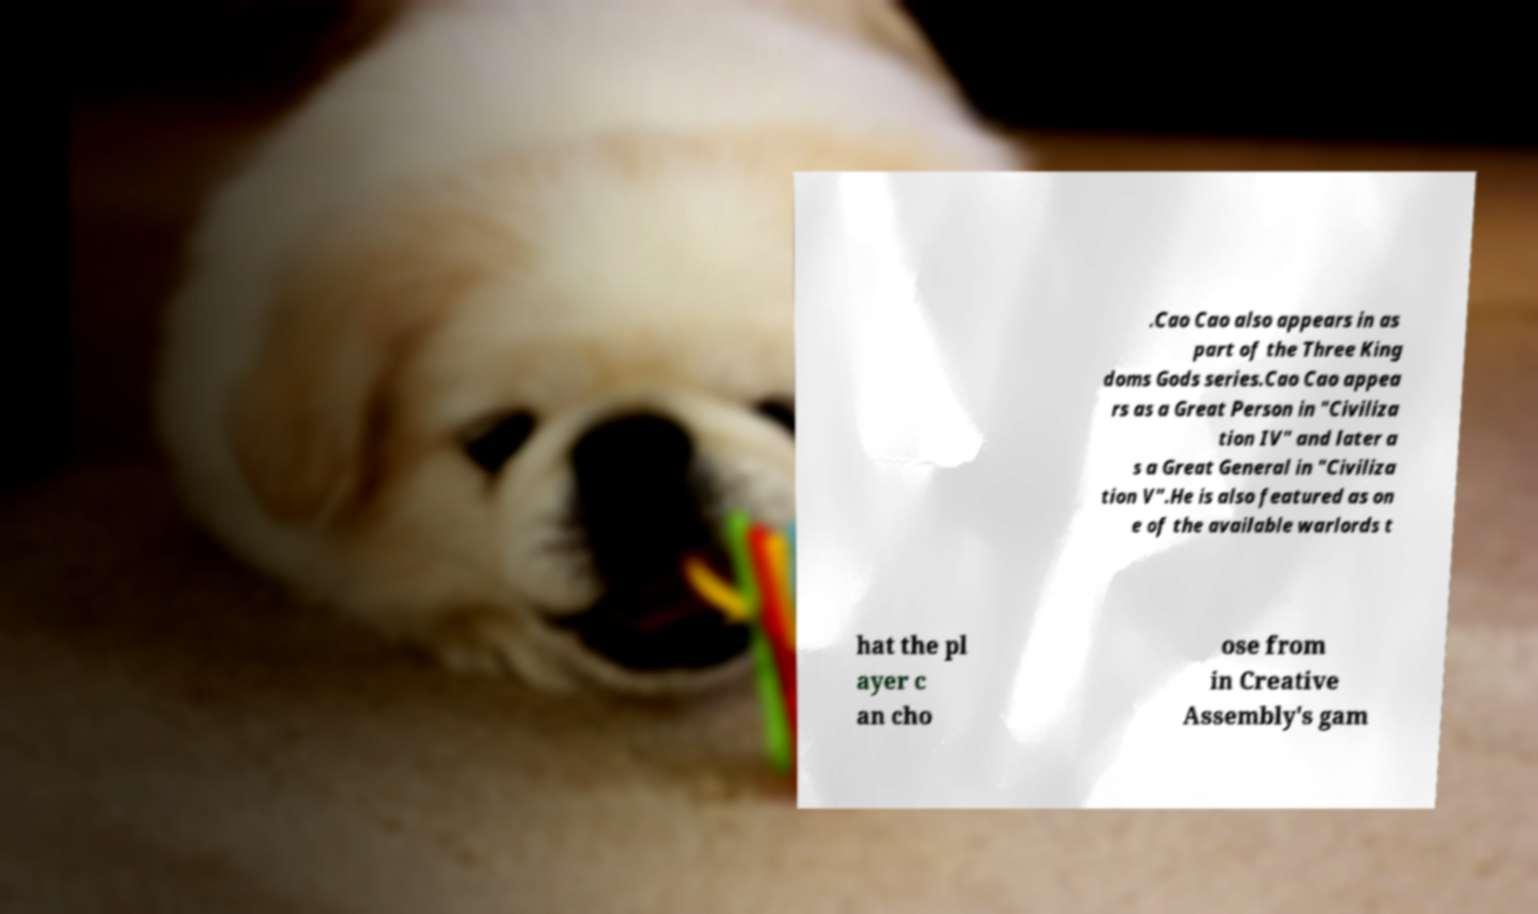Please read and relay the text visible in this image. What does it say? .Cao Cao also appears in as part of the Three King doms Gods series.Cao Cao appea rs as a Great Person in "Civiliza tion IV" and later a s a Great General in "Civiliza tion V".He is also featured as on e of the available warlords t hat the pl ayer c an cho ose from in Creative Assembly's gam 